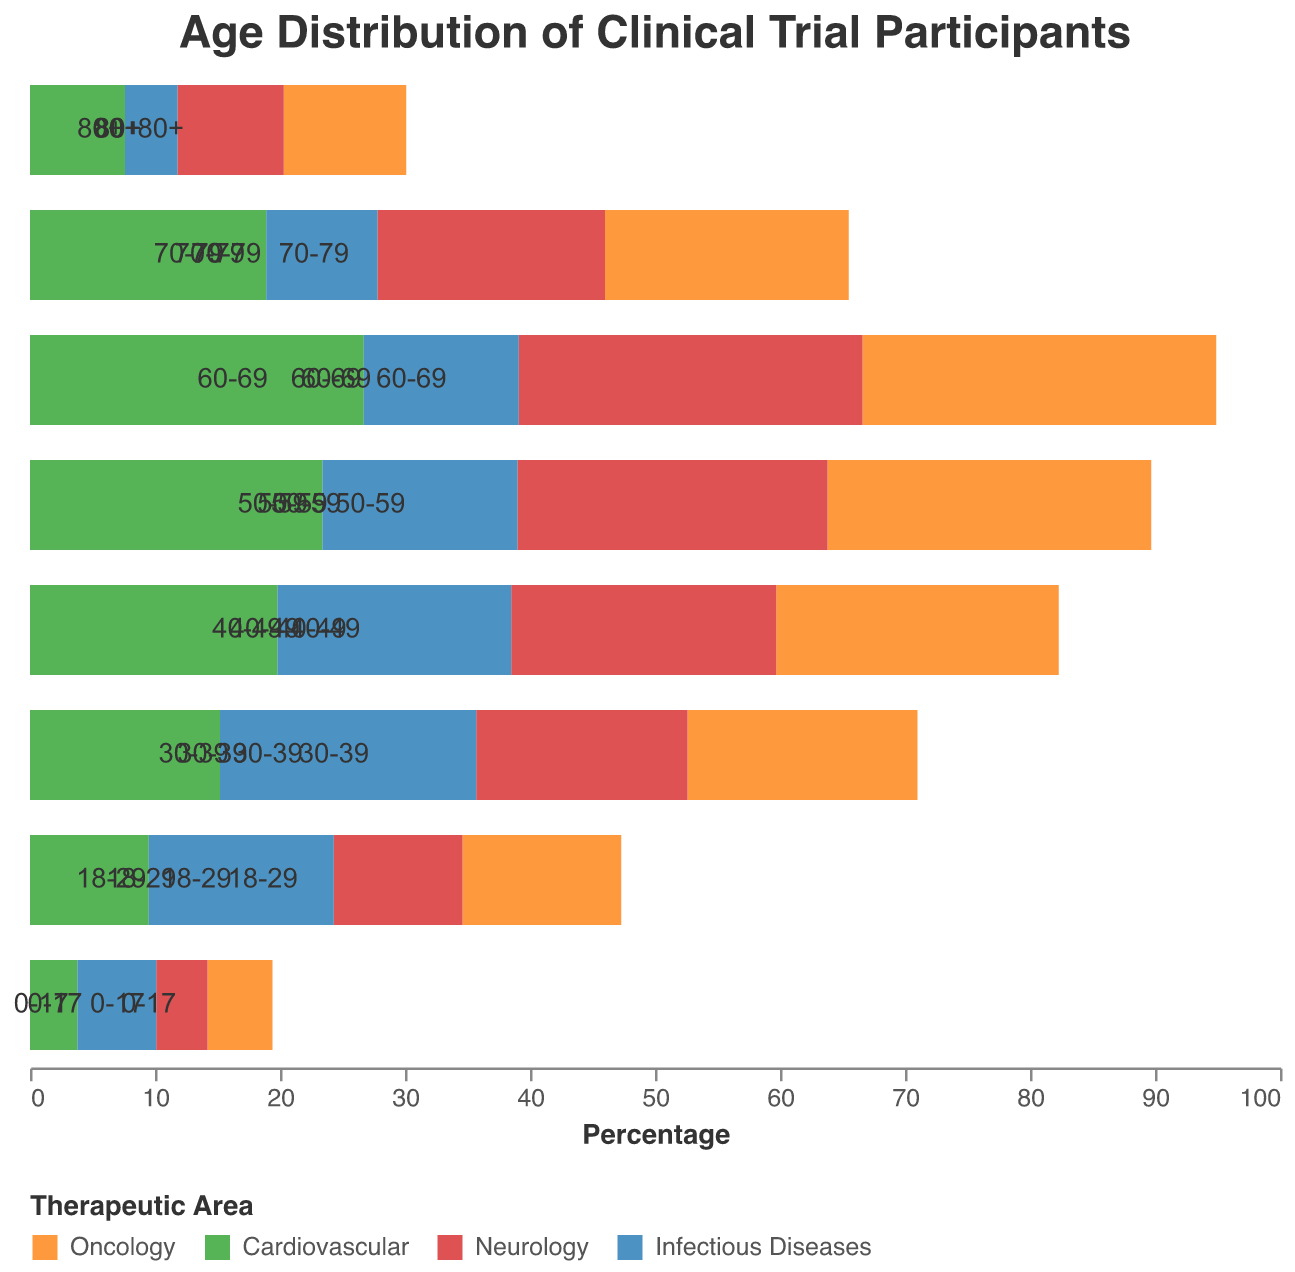Which therapeutic area has the highest percentage of participants in the 18-29 age group? To find this, look at the 18-29 row and compare the percentages for Oncology, Cardiovascular, Neurology, and Infectious Diseases. Infectious Diseases has the highest positive value (14.8).
Answer: Infectious Diseases Which age group has the highest percentage of participants in Oncology trials? Scan the Oncology column and identify the age group with the most negative value. The 60-69 age group has the highest negative percentage (-28.3).
Answer: 60-69 What is the sum of the percentages of Neurology and Oncology participants in the 30-39 age group? Add the percentages of Neurology and Oncology for the 30-39 age group: -16.9 (Neurology) + (-18.4) (Oncology) = -35.3.
Answer: -35.3 How does the percentage of Cardiovascular participants aged 50-59 compare to those aged 60-69? Look at the Cardiovascular percentages for the 50-59 and 60-69 age groups and compare the values: 23.4 (50-59) is less than 26.7 (60-69).
Answer: 50-59 < 60-69 What is the average percentage of participants in Infectious Diseases across all age groups? Sum the Infectious Diseases percentages and divide by the number of age groups: (6.3 + 14.8 + 20.5 + 18.7 + 15.6 + 12.4 + 8.9 + 4.2) / 8 = 12.675.
Answer: 12.675 Which therapeutic area has the lowest percentage of participants aged 70-79? Compare the values for the 70-79 age group across all therapeutic areas. Neurology has the lowest negative value (-18.2).
Answer: Neurology What is the difference in percentage of Cardiovascular participants between the 40-49 and 80+ age groups? Subtract the percentage for the 80+ age group from the 40-49 age group for Cardiovascular: 19.8 - 7.6 = 12.2.
Answer: 12.2 Which age group has the closest percentage of participants between Oncology and Neurology? Compare the values for all age groups and find the smallest difference in percentages between Oncology and Neurology. For the 70-79 age group: -19.5 (Oncology) and -18.2 (Neurology) have a difference of 1.3.
Answer: 70-79 